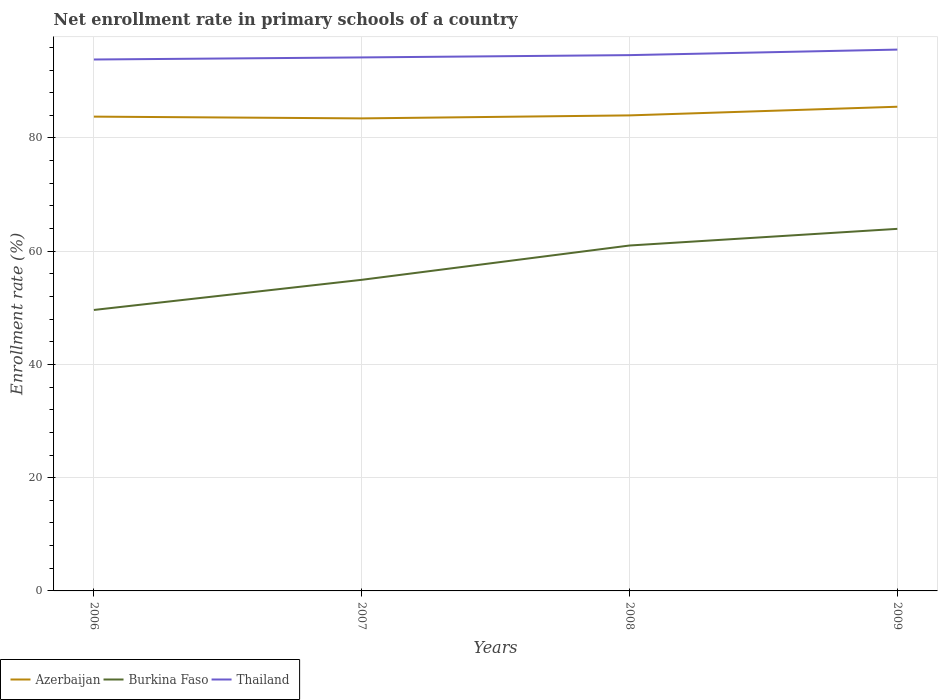Does the line corresponding to Azerbaijan intersect with the line corresponding to Thailand?
Provide a succinct answer. No. Across all years, what is the maximum enrollment rate in primary schools in Burkina Faso?
Give a very brief answer. 49.62. In which year was the enrollment rate in primary schools in Burkina Faso maximum?
Make the answer very short. 2006. What is the total enrollment rate in primary schools in Thailand in the graph?
Ensure brevity in your answer.  -0.98. What is the difference between the highest and the second highest enrollment rate in primary schools in Azerbaijan?
Provide a succinct answer. 2.06. What is the difference between the highest and the lowest enrollment rate in primary schools in Burkina Faso?
Offer a terse response. 2. Is the enrollment rate in primary schools in Azerbaijan strictly greater than the enrollment rate in primary schools in Burkina Faso over the years?
Keep it short and to the point. No. How many lines are there?
Offer a terse response. 3. Are the values on the major ticks of Y-axis written in scientific E-notation?
Your response must be concise. No. Does the graph contain grids?
Your response must be concise. Yes. What is the title of the graph?
Provide a short and direct response. Net enrollment rate in primary schools of a country. Does "Nicaragua" appear as one of the legend labels in the graph?
Provide a short and direct response. No. What is the label or title of the X-axis?
Make the answer very short. Years. What is the label or title of the Y-axis?
Your answer should be very brief. Enrollment rate (%). What is the Enrollment rate (%) in Azerbaijan in 2006?
Provide a short and direct response. 83.77. What is the Enrollment rate (%) of Burkina Faso in 2006?
Offer a very short reply. 49.62. What is the Enrollment rate (%) in Thailand in 2006?
Your response must be concise. 93.86. What is the Enrollment rate (%) in Azerbaijan in 2007?
Provide a succinct answer. 83.46. What is the Enrollment rate (%) of Burkina Faso in 2007?
Ensure brevity in your answer.  54.95. What is the Enrollment rate (%) of Thailand in 2007?
Your answer should be compact. 94.23. What is the Enrollment rate (%) in Azerbaijan in 2008?
Your response must be concise. 83.99. What is the Enrollment rate (%) in Burkina Faso in 2008?
Your response must be concise. 61.01. What is the Enrollment rate (%) in Thailand in 2008?
Provide a short and direct response. 94.63. What is the Enrollment rate (%) in Azerbaijan in 2009?
Keep it short and to the point. 85.52. What is the Enrollment rate (%) of Burkina Faso in 2009?
Give a very brief answer. 63.95. What is the Enrollment rate (%) in Thailand in 2009?
Provide a short and direct response. 95.61. Across all years, what is the maximum Enrollment rate (%) of Azerbaijan?
Keep it short and to the point. 85.52. Across all years, what is the maximum Enrollment rate (%) in Burkina Faso?
Provide a short and direct response. 63.95. Across all years, what is the maximum Enrollment rate (%) of Thailand?
Offer a terse response. 95.61. Across all years, what is the minimum Enrollment rate (%) in Azerbaijan?
Offer a very short reply. 83.46. Across all years, what is the minimum Enrollment rate (%) in Burkina Faso?
Your answer should be very brief. 49.62. Across all years, what is the minimum Enrollment rate (%) in Thailand?
Offer a very short reply. 93.86. What is the total Enrollment rate (%) of Azerbaijan in the graph?
Your answer should be compact. 336.74. What is the total Enrollment rate (%) in Burkina Faso in the graph?
Keep it short and to the point. 229.52. What is the total Enrollment rate (%) of Thailand in the graph?
Keep it short and to the point. 378.33. What is the difference between the Enrollment rate (%) in Azerbaijan in 2006 and that in 2007?
Provide a short and direct response. 0.31. What is the difference between the Enrollment rate (%) in Burkina Faso in 2006 and that in 2007?
Keep it short and to the point. -5.32. What is the difference between the Enrollment rate (%) of Thailand in 2006 and that in 2007?
Give a very brief answer. -0.37. What is the difference between the Enrollment rate (%) of Azerbaijan in 2006 and that in 2008?
Offer a very short reply. -0.22. What is the difference between the Enrollment rate (%) in Burkina Faso in 2006 and that in 2008?
Offer a very short reply. -11.38. What is the difference between the Enrollment rate (%) in Thailand in 2006 and that in 2008?
Offer a very short reply. -0.77. What is the difference between the Enrollment rate (%) in Azerbaijan in 2006 and that in 2009?
Ensure brevity in your answer.  -1.75. What is the difference between the Enrollment rate (%) in Burkina Faso in 2006 and that in 2009?
Keep it short and to the point. -14.33. What is the difference between the Enrollment rate (%) in Thailand in 2006 and that in 2009?
Offer a terse response. -1.75. What is the difference between the Enrollment rate (%) of Azerbaijan in 2007 and that in 2008?
Keep it short and to the point. -0.53. What is the difference between the Enrollment rate (%) of Burkina Faso in 2007 and that in 2008?
Give a very brief answer. -6.06. What is the difference between the Enrollment rate (%) in Thailand in 2007 and that in 2008?
Provide a short and direct response. -0.4. What is the difference between the Enrollment rate (%) in Azerbaijan in 2007 and that in 2009?
Offer a very short reply. -2.06. What is the difference between the Enrollment rate (%) of Burkina Faso in 2007 and that in 2009?
Offer a very short reply. -9. What is the difference between the Enrollment rate (%) in Thailand in 2007 and that in 2009?
Provide a short and direct response. -1.38. What is the difference between the Enrollment rate (%) in Azerbaijan in 2008 and that in 2009?
Your answer should be compact. -1.53. What is the difference between the Enrollment rate (%) of Burkina Faso in 2008 and that in 2009?
Provide a short and direct response. -2.94. What is the difference between the Enrollment rate (%) in Thailand in 2008 and that in 2009?
Ensure brevity in your answer.  -0.98. What is the difference between the Enrollment rate (%) of Azerbaijan in 2006 and the Enrollment rate (%) of Burkina Faso in 2007?
Your answer should be very brief. 28.83. What is the difference between the Enrollment rate (%) in Azerbaijan in 2006 and the Enrollment rate (%) in Thailand in 2007?
Ensure brevity in your answer.  -10.46. What is the difference between the Enrollment rate (%) of Burkina Faso in 2006 and the Enrollment rate (%) of Thailand in 2007?
Make the answer very short. -44.61. What is the difference between the Enrollment rate (%) in Azerbaijan in 2006 and the Enrollment rate (%) in Burkina Faso in 2008?
Make the answer very short. 22.77. What is the difference between the Enrollment rate (%) in Azerbaijan in 2006 and the Enrollment rate (%) in Thailand in 2008?
Offer a very short reply. -10.86. What is the difference between the Enrollment rate (%) in Burkina Faso in 2006 and the Enrollment rate (%) in Thailand in 2008?
Ensure brevity in your answer.  -45.01. What is the difference between the Enrollment rate (%) of Azerbaijan in 2006 and the Enrollment rate (%) of Burkina Faso in 2009?
Make the answer very short. 19.82. What is the difference between the Enrollment rate (%) in Azerbaijan in 2006 and the Enrollment rate (%) in Thailand in 2009?
Offer a terse response. -11.84. What is the difference between the Enrollment rate (%) of Burkina Faso in 2006 and the Enrollment rate (%) of Thailand in 2009?
Make the answer very short. -45.99. What is the difference between the Enrollment rate (%) in Azerbaijan in 2007 and the Enrollment rate (%) in Burkina Faso in 2008?
Make the answer very short. 22.45. What is the difference between the Enrollment rate (%) of Azerbaijan in 2007 and the Enrollment rate (%) of Thailand in 2008?
Offer a very short reply. -11.17. What is the difference between the Enrollment rate (%) of Burkina Faso in 2007 and the Enrollment rate (%) of Thailand in 2008?
Keep it short and to the point. -39.69. What is the difference between the Enrollment rate (%) in Azerbaijan in 2007 and the Enrollment rate (%) in Burkina Faso in 2009?
Keep it short and to the point. 19.51. What is the difference between the Enrollment rate (%) of Azerbaijan in 2007 and the Enrollment rate (%) of Thailand in 2009?
Keep it short and to the point. -12.15. What is the difference between the Enrollment rate (%) in Burkina Faso in 2007 and the Enrollment rate (%) in Thailand in 2009?
Ensure brevity in your answer.  -40.66. What is the difference between the Enrollment rate (%) in Azerbaijan in 2008 and the Enrollment rate (%) in Burkina Faso in 2009?
Keep it short and to the point. 20.04. What is the difference between the Enrollment rate (%) in Azerbaijan in 2008 and the Enrollment rate (%) in Thailand in 2009?
Offer a very short reply. -11.62. What is the difference between the Enrollment rate (%) in Burkina Faso in 2008 and the Enrollment rate (%) in Thailand in 2009?
Offer a terse response. -34.6. What is the average Enrollment rate (%) in Azerbaijan per year?
Make the answer very short. 84.18. What is the average Enrollment rate (%) in Burkina Faso per year?
Provide a succinct answer. 57.38. What is the average Enrollment rate (%) in Thailand per year?
Your response must be concise. 94.58. In the year 2006, what is the difference between the Enrollment rate (%) of Azerbaijan and Enrollment rate (%) of Burkina Faso?
Provide a short and direct response. 34.15. In the year 2006, what is the difference between the Enrollment rate (%) in Azerbaijan and Enrollment rate (%) in Thailand?
Your answer should be compact. -10.09. In the year 2006, what is the difference between the Enrollment rate (%) in Burkina Faso and Enrollment rate (%) in Thailand?
Make the answer very short. -44.24. In the year 2007, what is the difference between the Enrollment rate (%) of Azerbaijan and Enrollment rate (%) of Burkina Faso?
Make the answer very short. 28.51. In the year 2007, what is the difference between the Enrollment rate (%) of Azerbaijan and Enrollment rate (%) of Thailand?
Provide a short and direct response. -10.77. In the year 2007, what is the difference between the Enrollment rate (%) in Burkina Faso and Enrollment rate (%) in Thailand?
Your response must be concise. -39.28. In the year 2008, what is the difference between the Enrollment rate (%) in Azerbaijan and Enrollment rate (%) in Burkina Faso?
Keep it short and to the point. 22.98. In the year 2008, what is the difference between the Enrollment rate (%) in Azerbaijan and Enrollment rate (%) in Thailand?
Make the answer very short. -10.65. In the year 2008, what is the difference between the Enrollment rate (%) in Burkina Faso and Enrollment rate (%) in Thailand?
Give a very brief answer. -33.63. In the year 2009, what is the difference between the Enrollment rate (%) of Azerbaijan and Enrollment rate (%) of Burkina Faso?
Provide a short and direct response. 21.57. In the year 2009, what is the difference between the Enrollment rate (%) of Azerbaijan and Enrollment rate (%) of Thailand?
Provide a succinct answer. -10.09. In the year 2009, what is the difference between the Enrollment rate (%) of Burkina Faso and Enrollment rate (%) of Thailand?
Keep it short and to the point. -31.66. What is the ratio of the Enrollment rate (%) of Azerbaijan in 2006 to that in 2007?
Ensure brevity in your answer.  1. What is the ratio of the Enrollment rate (%) in Burkina Faso in 2006 to that in 2007?
Ensure brevity in your answer.  0.9. What is the ratio of the Enrollment rate (%) of Thailand in 2006 to that in 2007?
Keep it short and to the point. 1. What is the ratio of the Enrollment rate (%) of Burkina Faso in 2006 to that in 2008?
Offer a terse response. 0.81. What is the ratio of the Enrollment rate (%) in Azerbaijan in 2006 to that in 2009?
Provide a succinct answer. 0.98. What is the ratio of the Enrollment rate (%) in Burkina Faso in 2006 to that in 2009?
Your answer should be very brief. 0.78. What is the ratio of the Enrollment rate (%) in Thailand in 2006 to that in 2009?
Your answer should be compact. 0.98. What is the ratio of the Enrollment rate (%) of Burkina Faso in 2007 to that in 2008?
Your answer should be compact. 0.9. What is the ratio of the Enrollment rate (%) in Azerbaijan in 2007 to that in 2009?
Your response must be concise. 0.98. What is the ratio of the Enrollment rate (%) of Burkina Faso in 2007 to that in 2009?
Your response must be concise. 0.86. What is the ratio of the Enrollment rate (%) in Thailand in 2007 to that in 2009?
Your answer should be very brief. 0.99. What is the ratio of the Enrollment rate (%) in Azerbaijan in 2008 to that in 2009?
Offer a very short reply. 0.98. What is the ratio of the Enrollment rate (%) of Burkina Faso in 2008 to that in 2009?
Ensure brevity in your answer.  0.95. What is the difference between the highest and the second highest Enrollment rate (%) in Azerbaijan?
Your answer should be compact. 1.53. What is the difference between the highest and the second highest Enrollment rate (%) of Burkina Faso?
Your answer should be compact. 2.94. What is the difference between the highest and the lowest Enrollment rate (%) of Azerbaijan?
Your response must be concise. 2.06. What is the difference between the highest and the lowest Enrollment rate (%) in Burkina Faso?
Provide a succinct answer. 14.33. What is the difference between the highest and the lowest Enrollment rate (%) of Thailand?
Provide a succinct answer. 1.75. 